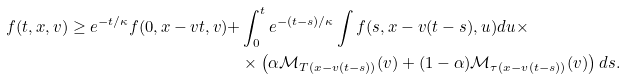Convert formula to latex. <formula><loc_0><loc_0><loc_500><loc_500>f ( t , x , v ) \geq e ^ { - t / \kappa } f ( 0 , x - v t , v ) + & \int _ { 0 } ^ { t } e ^ { - ( t - s ) / \kappa } \int f ( s , x - v ( t - s ) , u ) d u \times \\ & \times \left ( \alpha \mathcal { M } _ { T ( x - v ( t - s ) ) } ( v ) + ( 1 - \alpha ) \mathcal { M } _ { \tau ( x - v ( t - s ) ) } ( v ) \right ) d s .</formula> 